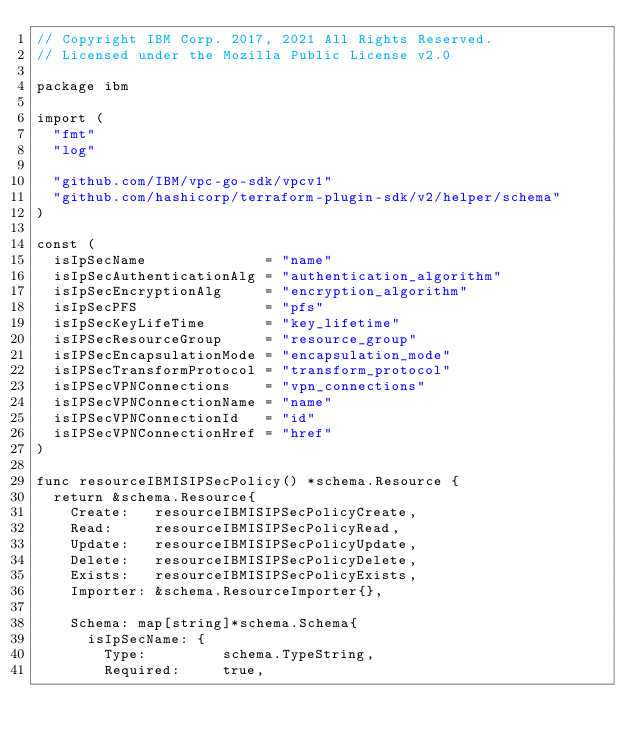<code> <loc_0><loc_0><loc_500><loc_500><_Go_>// Copyright IBM Corp. 2017, 2021 All Rights Reserved.
// Licensed under the Mozilla Public License v2.0

package ibm

import (
	"fmt"
	"log"

	"github.com/IBM/vpc-go-sdk/vpcv1"
	"github.com/hashicorp/terraform-plugin-sdk/v2/helper/schema"
)

const (
	isIpSecName              = "name"
	isIpSecAuthenticationAlg = "authentication_algorithm"
	isIpSecEncryptionAlg     = "encryption_algorithm"
	isIpSecPFS               = "pfs"
	isIpSecKeyLifeTime       = "key_lifetime"
	isIPSecResourceGroup     = "resource_group"
	isIPSecEncapsulationMode = "encapsulation_mode"
	isIPSecTransformProtocol = "transform_protocol"
	isIPSecVPNConnections    = "vpn_connections"
	isIPSecVPNConnectionName = "name"
	isIPSecVPNConnectionId   = "id"
	isIPSecVPNConnectionHref = "href"
)

func resourceIBMISIPSecPolicy() *schema.Resource {
	return &schema.Resource{
		Create:   resourceIBMISIPSecPolicyCreate,
		Read:     resourceIBMISIPSecPolicyRead,
		Update:   resourceIBMISIPSecPolicyUpdate,
		Delete:   resourceIBMISIPSecPolicyDelete,
		Exists:   resourceIBMISIPSecPolicyExists,
		Importer: &schema.ResourceImporter{},

		Schema: map[string]*schema.Schema{
			isIpSecName: {
				Type:         schema.TypeString,
				Required:     true,</code> 